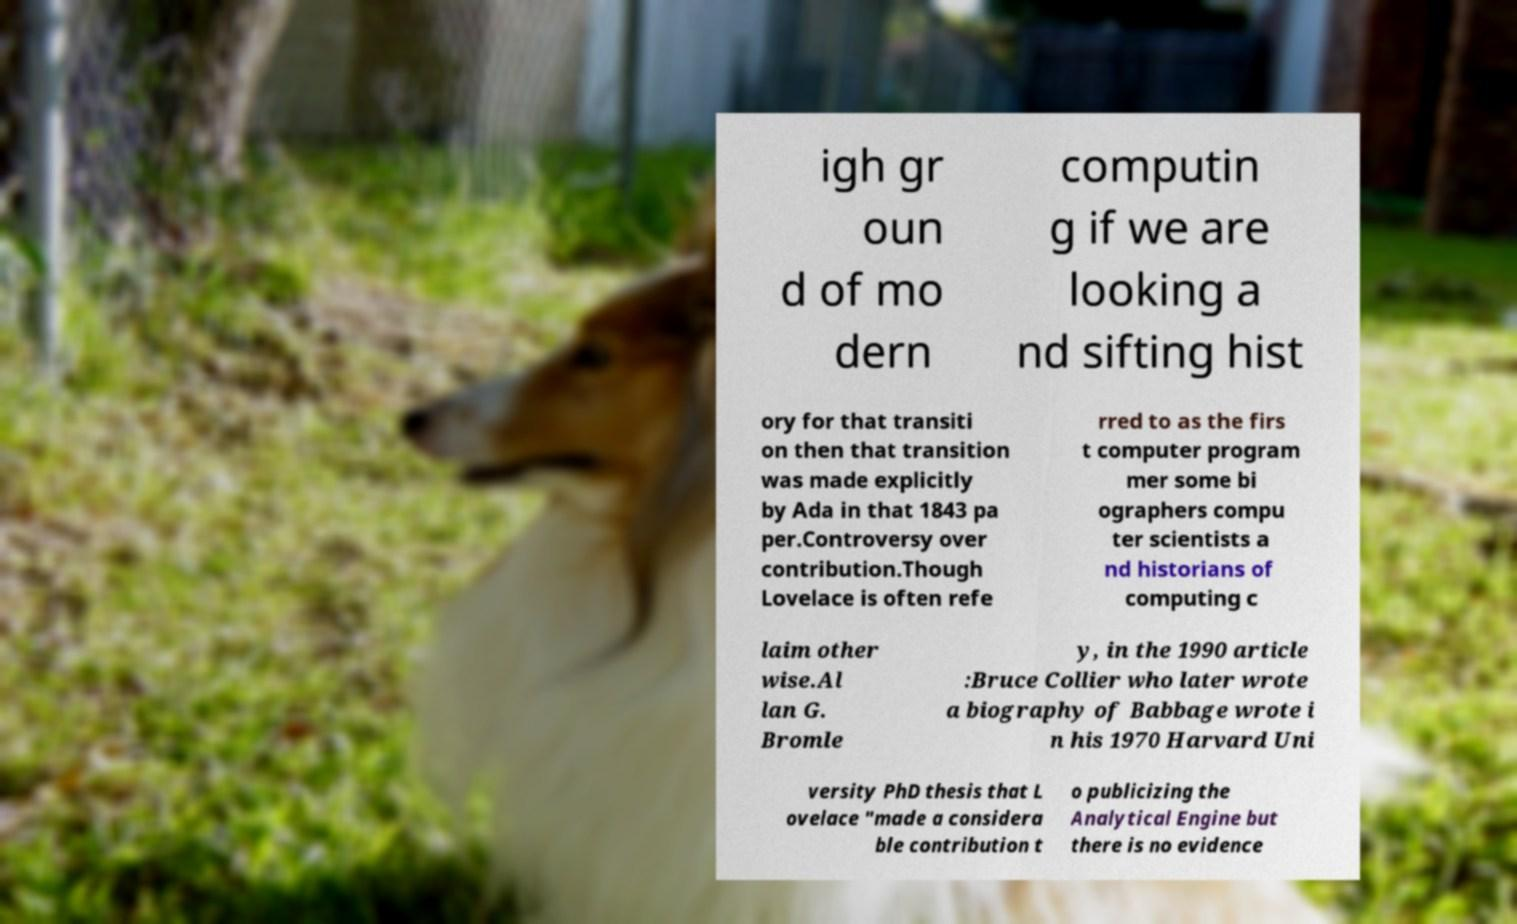Please identify and transcribe the text found in this image. igh gr oun d of mo dern computin g if we are looking a nd sifting hist ory for that transiti on then that transition was made explicitly by Ada in that 1843 pa per.Controversy over contribution.Though Lovelace is often refe rred to as the firs t computer program mer some bi ographers compu ter scientists a nd historians of computing c laim other wise.Al lan G. Bromle y, in the 1990 article :Bruce Collier who later wrote a biography of Babbage wrote i n his 1970 Harvard Uni versity PhD thesis that L ovelace "made a considera ble contribution t o publicizing the Analytical Engine but there is no evidence 